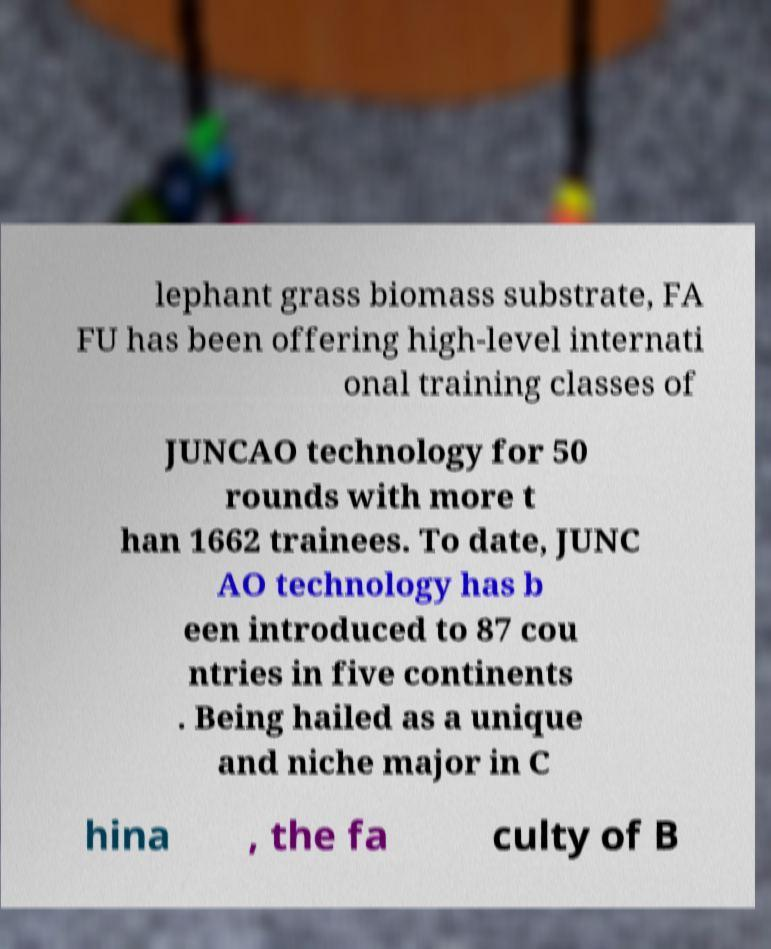Could you assist in decoding the text presented in this image and type it out clearly? lephant grass biomass substrate, FA FU has been offering high-level internati onal training classes of JUNCAO technology for 50 rounds with more t han 1662 trainees. To date, JUNC AO technology has b een introduced to 87 cou ntries in five continents . Being hailed as a unique and niche major in C hina , the fa culty of B 